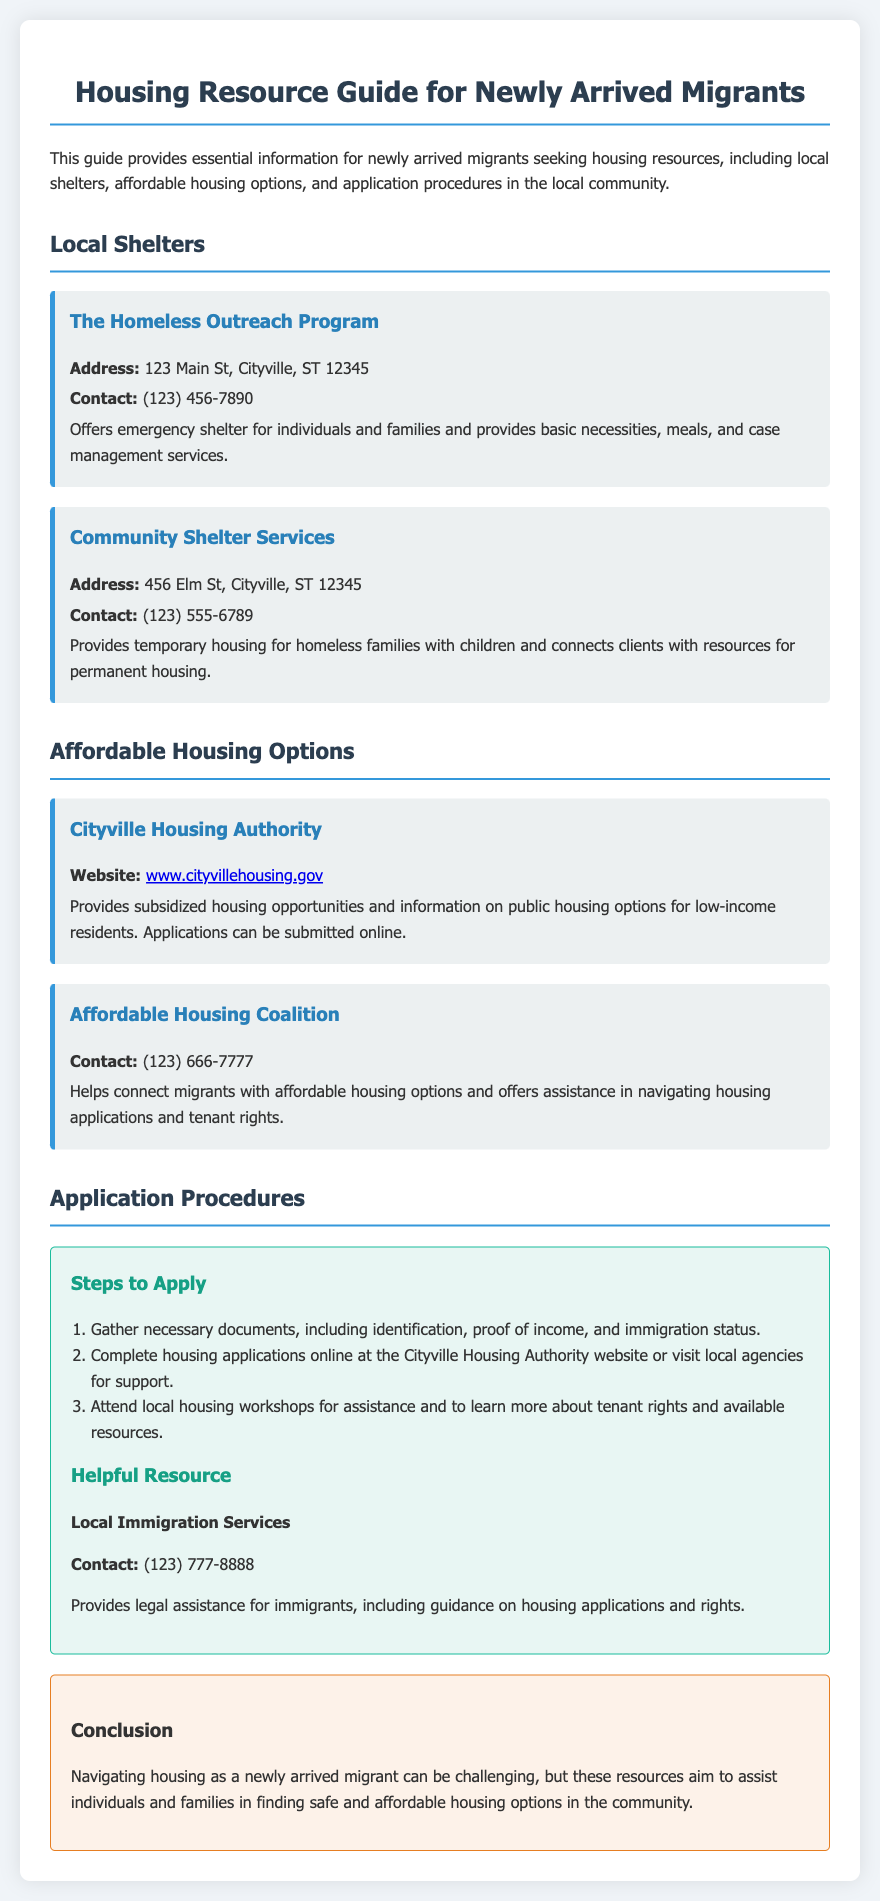What is the address of The Homeless Outreach Program? The address of The Homeless Outreach Program is listed in the document, which is 123 Main St, Cityville, ST 12345.
Answer: 123 Main St, Cityville, ST 12345 What type of housing does Community Shelter Services provide? The document specifies that Community Shelter Services provides temporary housing for homeless families with children.
Answer: Temporary housing for homeless families with children What is the contact number for the Affordable Housing Coalition? The document provides the contact number for the Affordable Housing Coalition as (123) 666-7777.
Answer: (123) 666-7777 How many steps are there to apply for housing? The document lists three steps to apply for housing in the application procedures section.
Answer: Three What should you gather before applying for housing? The document mentions necessary documents required for the application, which include identification, proof of income, and immigration status.
Answer: Identification, proof of income, immigration status Where can housing applications be submitted? The Cityville Housing Authority website is stated in the document as the place to submit housing applications online.
Answer: Cityville Housing Authority website What is offered at the local immigration services? The document outlines that local immigration services provide legal assistance for immigrants, including guidance on housing applications and rights.
Answer: Legal assistance What color is the background of the resource guide? The background color of the resource guide is specified in the style section of the document as #f0f4f8.
Answer: #f0f4f8 